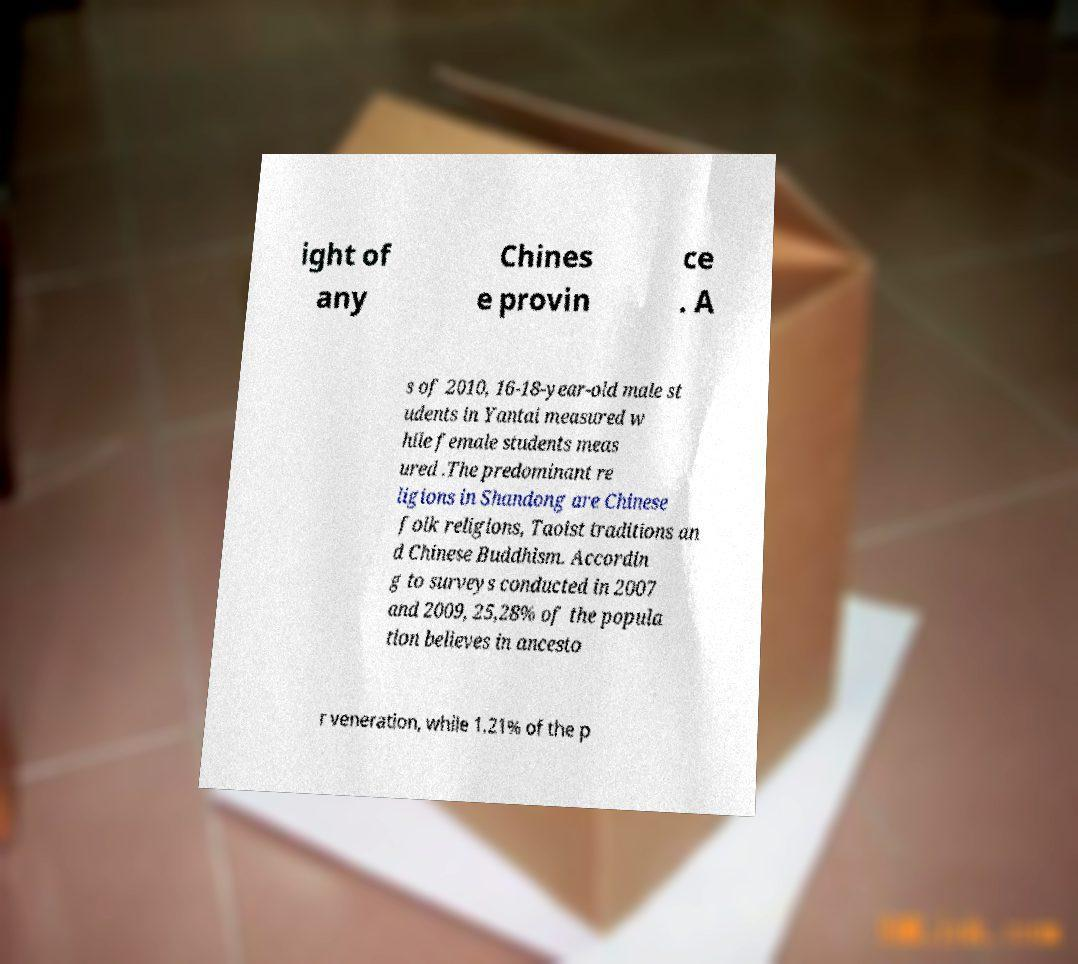Could you extract and type out the text from this image? ight of any Chines e provin ce . A s of 2010, 16-18-year-old male st udents in Yantai measured w hile female students meas ured .The predominant re ligions in Shandong are Chinese folk religions, Taoist traditions an d Chinese Buddhism. Accordin g to surveys conducted in 2007 and 2009, 25,28% of the popula tion believes in ancesto r veneration, while 1.21% of the p 